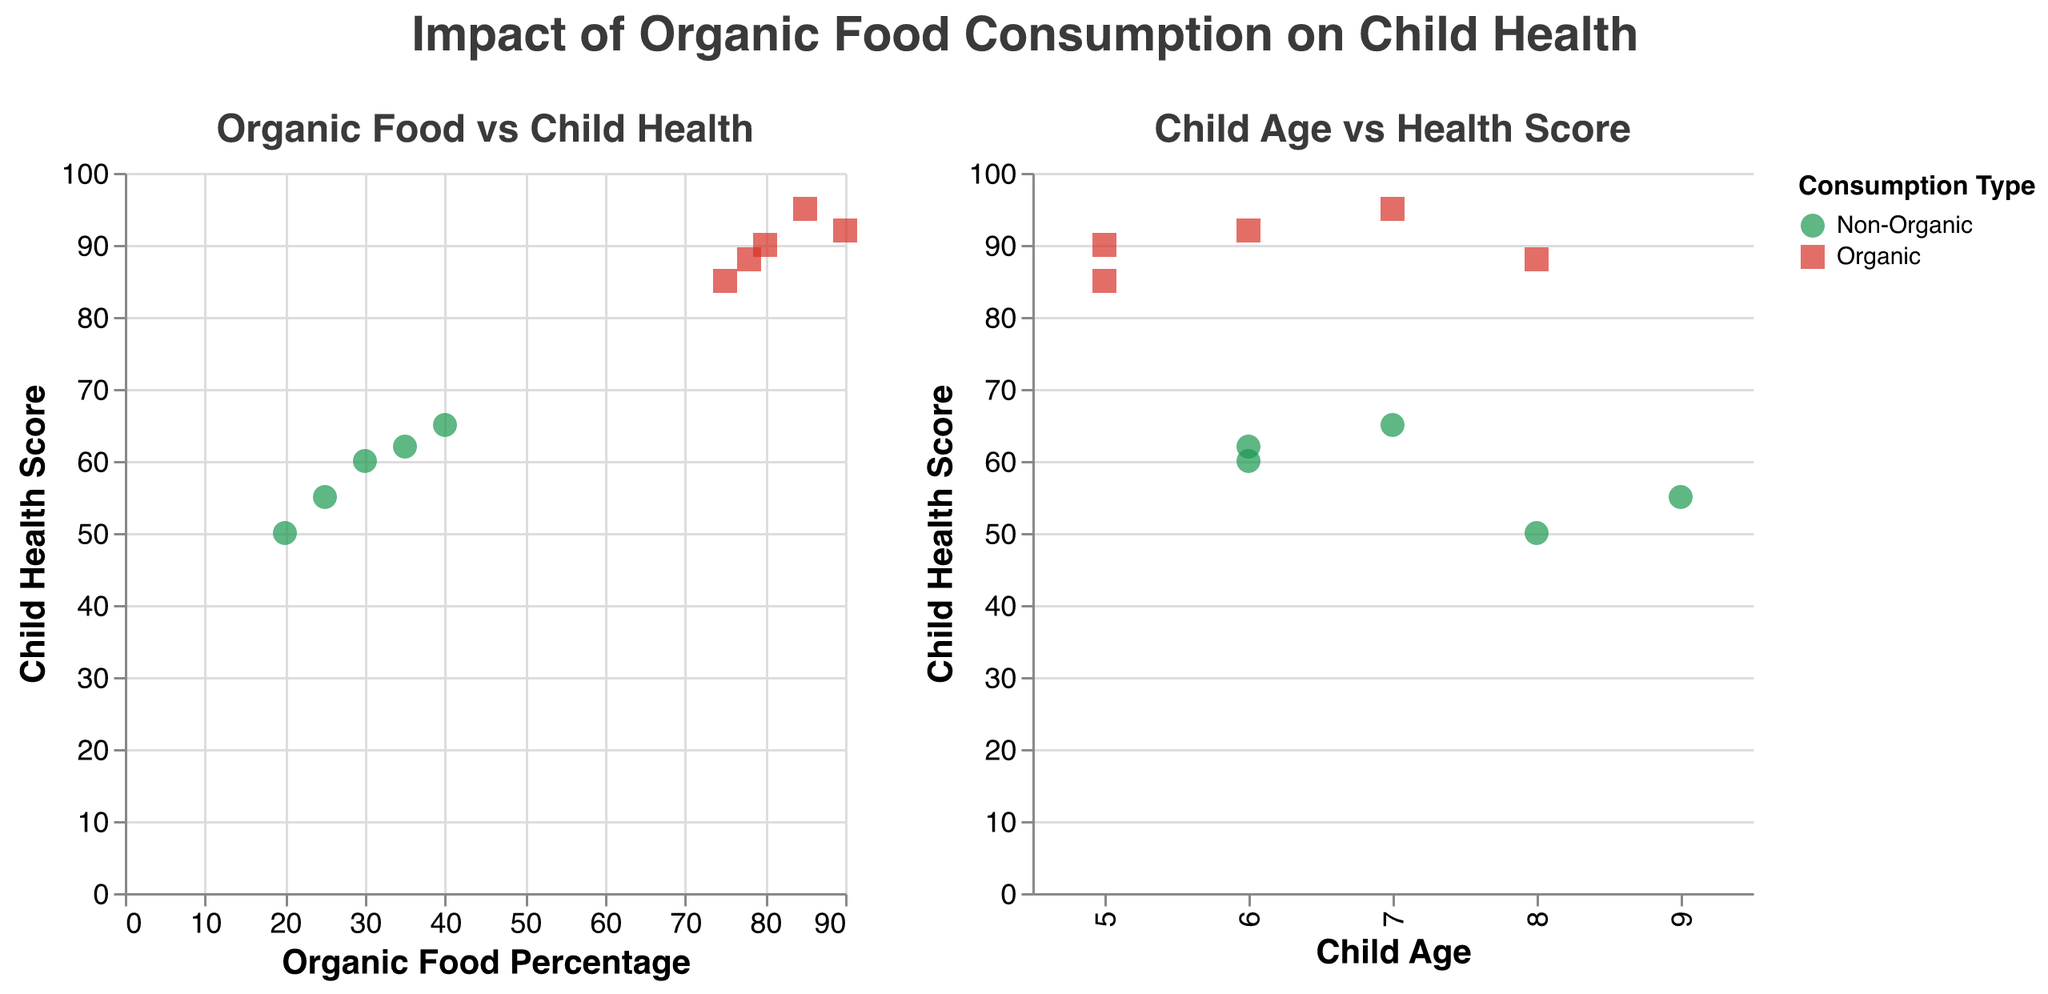What is the title of the figure? The title is found at the top of the figure, which summarizes the overall theme or main takeaway of the plot.
Answer: Impact of Organic Food Consumption on Child Health How many data points represent organic food consumption? Count the number of points in the plot which are colored according to the legend that indicates organic food consumption. There are 5 green points.
Answer: 5 What is the average Child Health Score for households with organic food consumption? Identify the Child Health Scores for households with organic consumption: 90, 95, 85, 92, 88. The sum is 450, and there are 5 households. Average = 450/5.
Answer: 90 Compare the Child Health Score of the 5-year-old child in the Organic group to that in the Non-Organic group. Which one is higher? From the tooltip, find the Child Health Scores for 5-year-olds: Organic (90), Non-Organic (85). 90 is higher than 85.
Answer: Organic Which age group in the Non-Organic households has the lowest health score? Examine the health scores for each age in Non-Organic households using the tooltip: 6 (60), 8 (50), 9 (55), 7 (65), 6 (62). The lowest is 50 for age 8.
Answer: 8 Which has a higher average Child Health Score as a group: households with 90% Organic food or households with 25% Non-Organic food? Calculate the average for groups:
- 90% Organic: Scores are 92.
- 25% Non-Organic: Scores are 55.
92 is higher than 55.
Answer: 90% Organic How does Child Health Score vary with increasing Organic Food Percentage? Observe the general trend in the scatter plot "Organic Food vs Child Health". Generally, as the Organic Percentage increases, the Child Health Score also tends to be higher.
Answer: Increases 